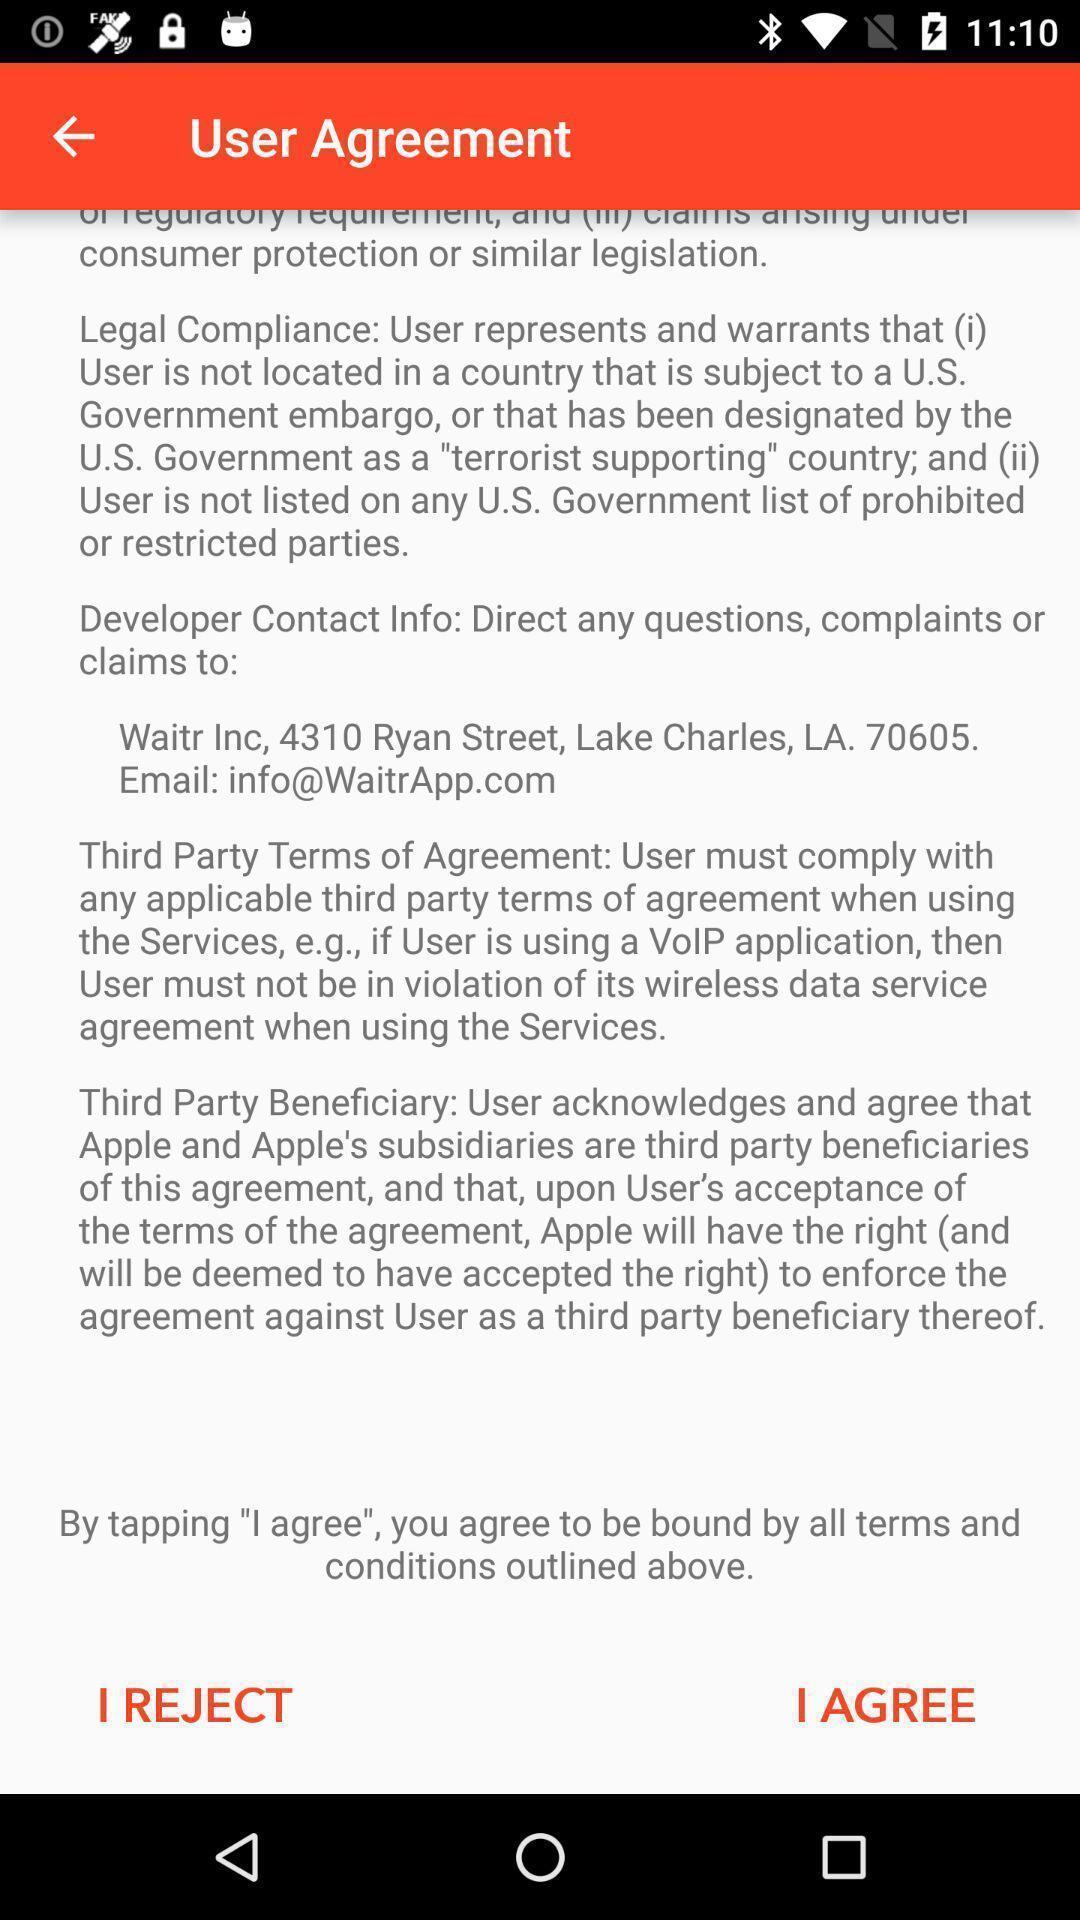Provide a textual representation of this image. User agreement page displayed. 